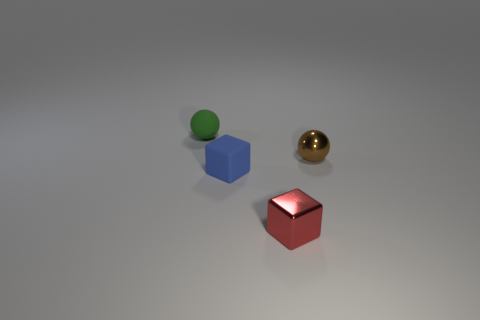Are there more blue rubber objects than cyan cylinders? Upon reviewing the image, there appears to be only one blue cube and no cyan cylinders. Therefore, the statement that there are more blue rubber objects than cyan cylinders is accurate, as the count of blue objects is one and cyan cylinders are none. 